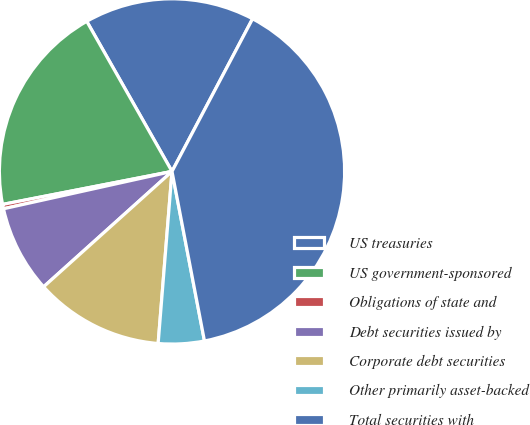<chart> <loc_0><loc_0><loc_500><loc_500><pie_chart><fcel>US treasuries<fcel>US government-sponsored<fcel>Obligations of state and<fcel>Debt securities issued by<fcel>Corporate debt securities<fcel>Other primarily asset-backed<fcel>Total securities with<nl><fcel>15.95%<fcel>19.84%<fcel>0.41%<fcel>8.18%<fcel>12.07%<fcel>4.29%<fcel>39.26%<nl></chart> 